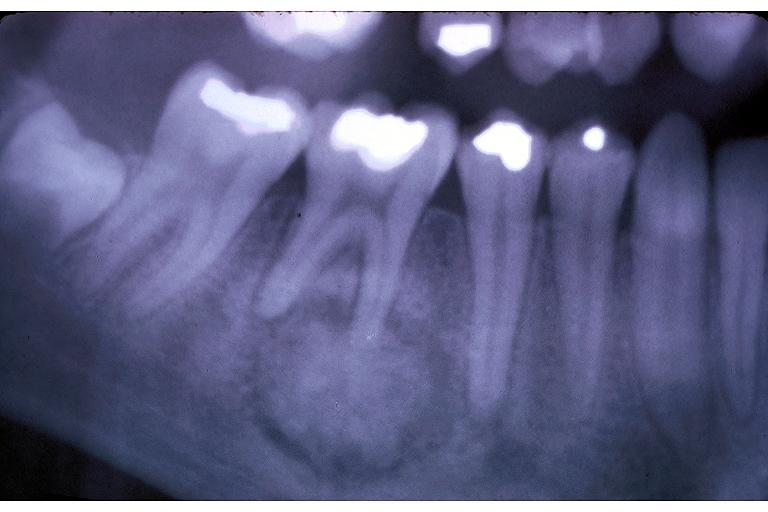where is this?
Answer the question using a single word or phrase. Oral 